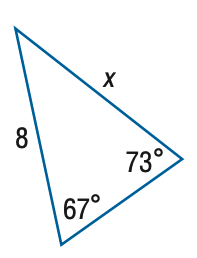Question: Find x. Round side measure to the nearest tenth.
Choices:
A. 5.4
B. 7.7
C. 8.3
D. 11.9
Answer with the letter. Answer: B 